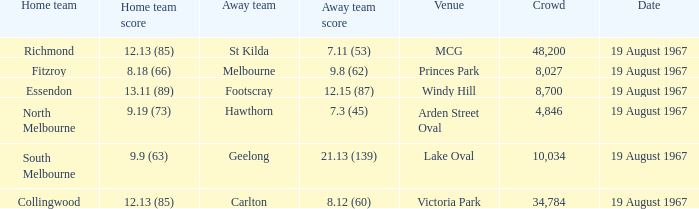3 (45), what was the score of the home team? 9.19 (73). 